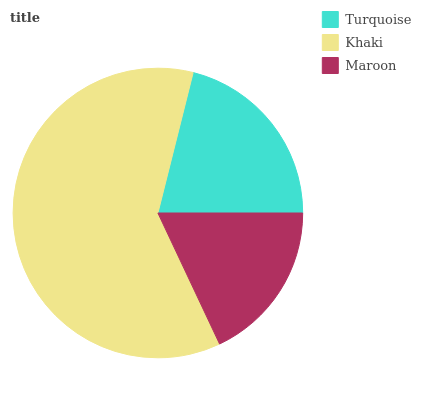Is Maroon the minimum?
Answer yes or no. Yes. Is Khaki the maximum?
Answer yes or no. Yes. Is Khaki the minimum?
Answer yes or no. No. Is Maroon the maximum?
Answer yes or no. No. Is Khaki greater than Maroon?
Answer yes or no. Yes. Is Maroon less than Khaki?
Answer yes or no. Yes. Is Maroon greater than Khaki?
Answer yes or no. No. Is Khaki less than Maroon?
Answer yes or no. No. Is Turquoise the high median?
Answer yes or no. Yes. Is Turquoise the low median?
Answer yes or no. Yes. Is Maroon the high median?
Answer yes or no. No. Is Khaki the low median?
Answer yes or no. No. 